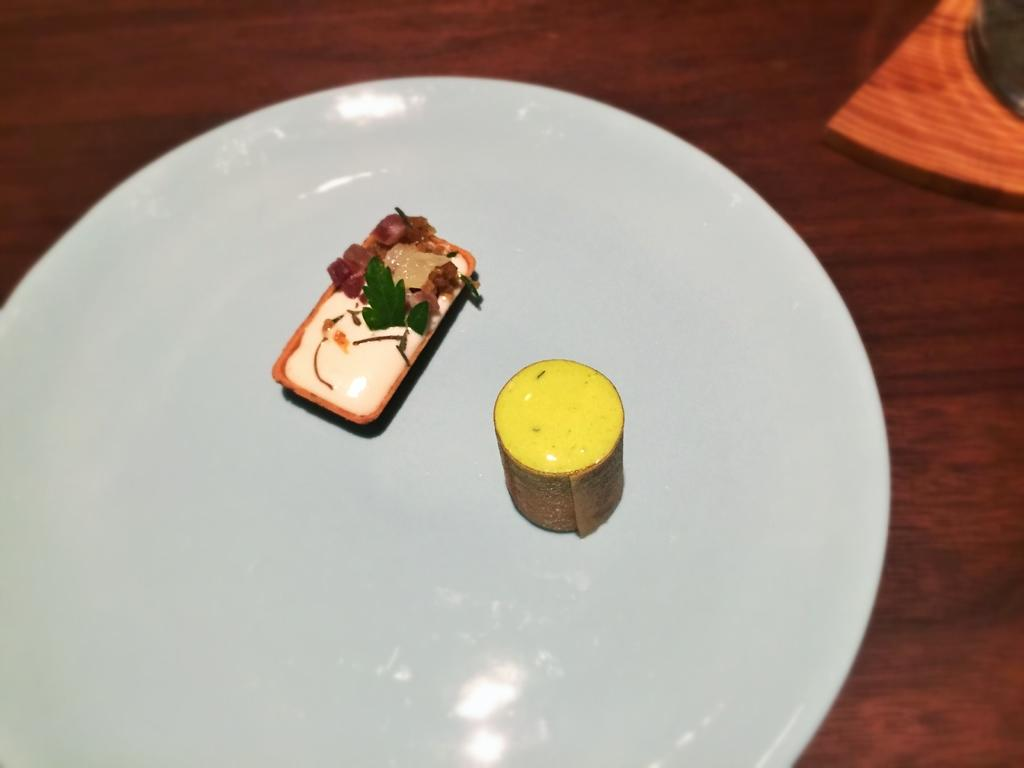What is present on the plate in the image? The food items are placed on a plate in the image. Where is the plate located? The plate is on a table in the image. What type of linen is draped over the food items in the image? There is no linen present in the image; the food items are placed directly on the plate. 